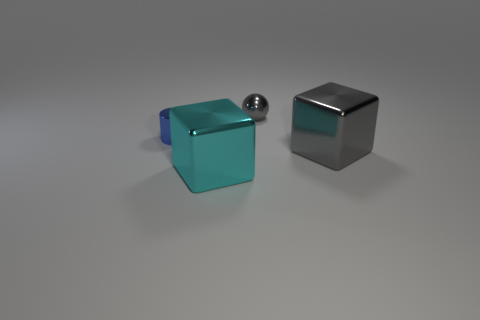Subtract all green cubes. Subtract all red cylinders. How many cubes are left? 2 Add 4 tiny blue metal cylinders. How many objects exist? 8 Subtract all balls. How many objects are left? 3 Subtract 0 red balls. How many objects are left? 4 Subtract all small gray metallic spheres. Subtract all tiny gray things. How many objects are left? 2 Add 2 blue cylinders. How many blue cylinders are left? 3 Add 3 tiny balls. How many tiny balls exist? 4 